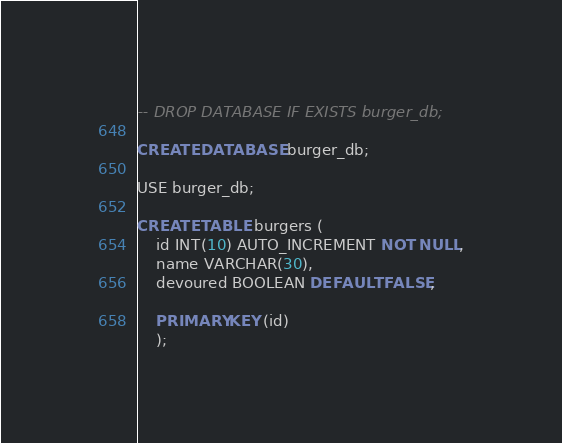<code> <loc_0><loc_0><loc_500><loc_500><_SQL_>-- DROP DATABASE IF EXISTS burger_db;

CREATE DATABASE burger_db;

USE burger_db;

CREATE TABLE burgers (
	id INT(10) AUTO_INCREMENT NOT NULL,
    name VARCHAR(30),
    devoured BOOLEAN DEFAULT FALSE,
    
    PRIMARY KEY (id)
    );</code> 